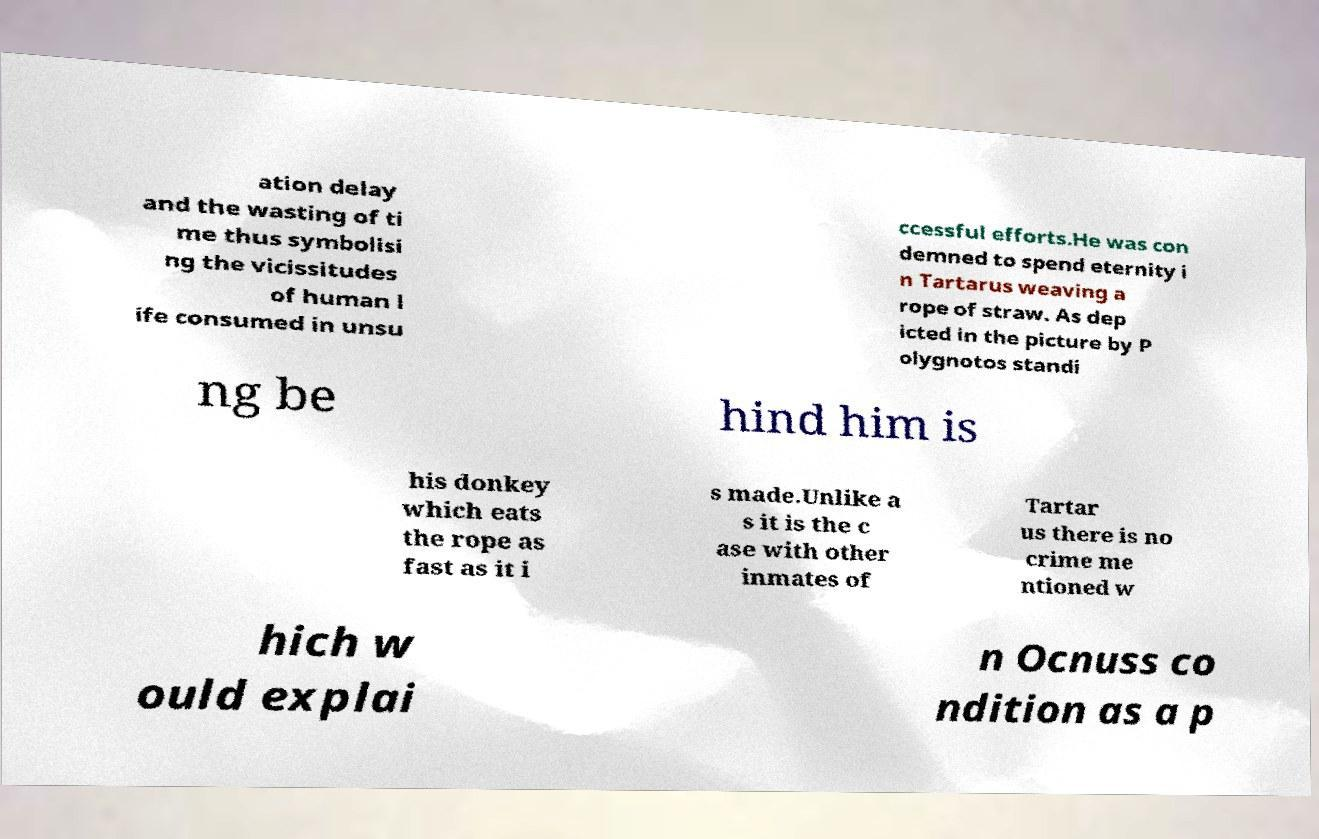Can you accurately transcribe the text from the provided image for me? ation delay and the wasting of ti me thus symbolisi ng the vicissitudes of human l ife consumed in unsu ccessful efforts.He was con demned to spend eternity i n Tartarus weaving a rope of straw. As dep icted in the picture by P olygnotos standi ng be hind him is his donkey which eats the rope as fast as it i s made.Unlike a s it is the c ase with other inmates of Tartar us there is no crime me ntioned w hich w ould explai n Ocnuss co ndition as a p 